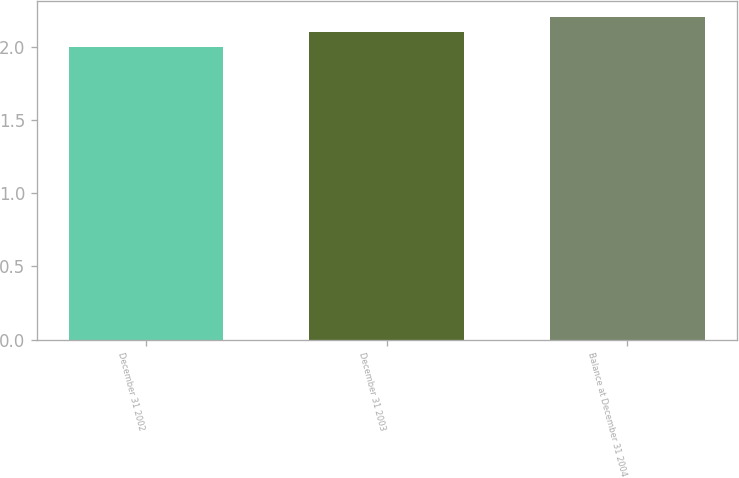<chart> <loc_0><loc_0><loc_500><loc_500><bar_chart><fcel>December 31 2002<fcel>December 31 2003<fcel>Balance at December 31 2004<nl><fcel>2<fcel>2.1<fcel>2.2<nl></chart> 